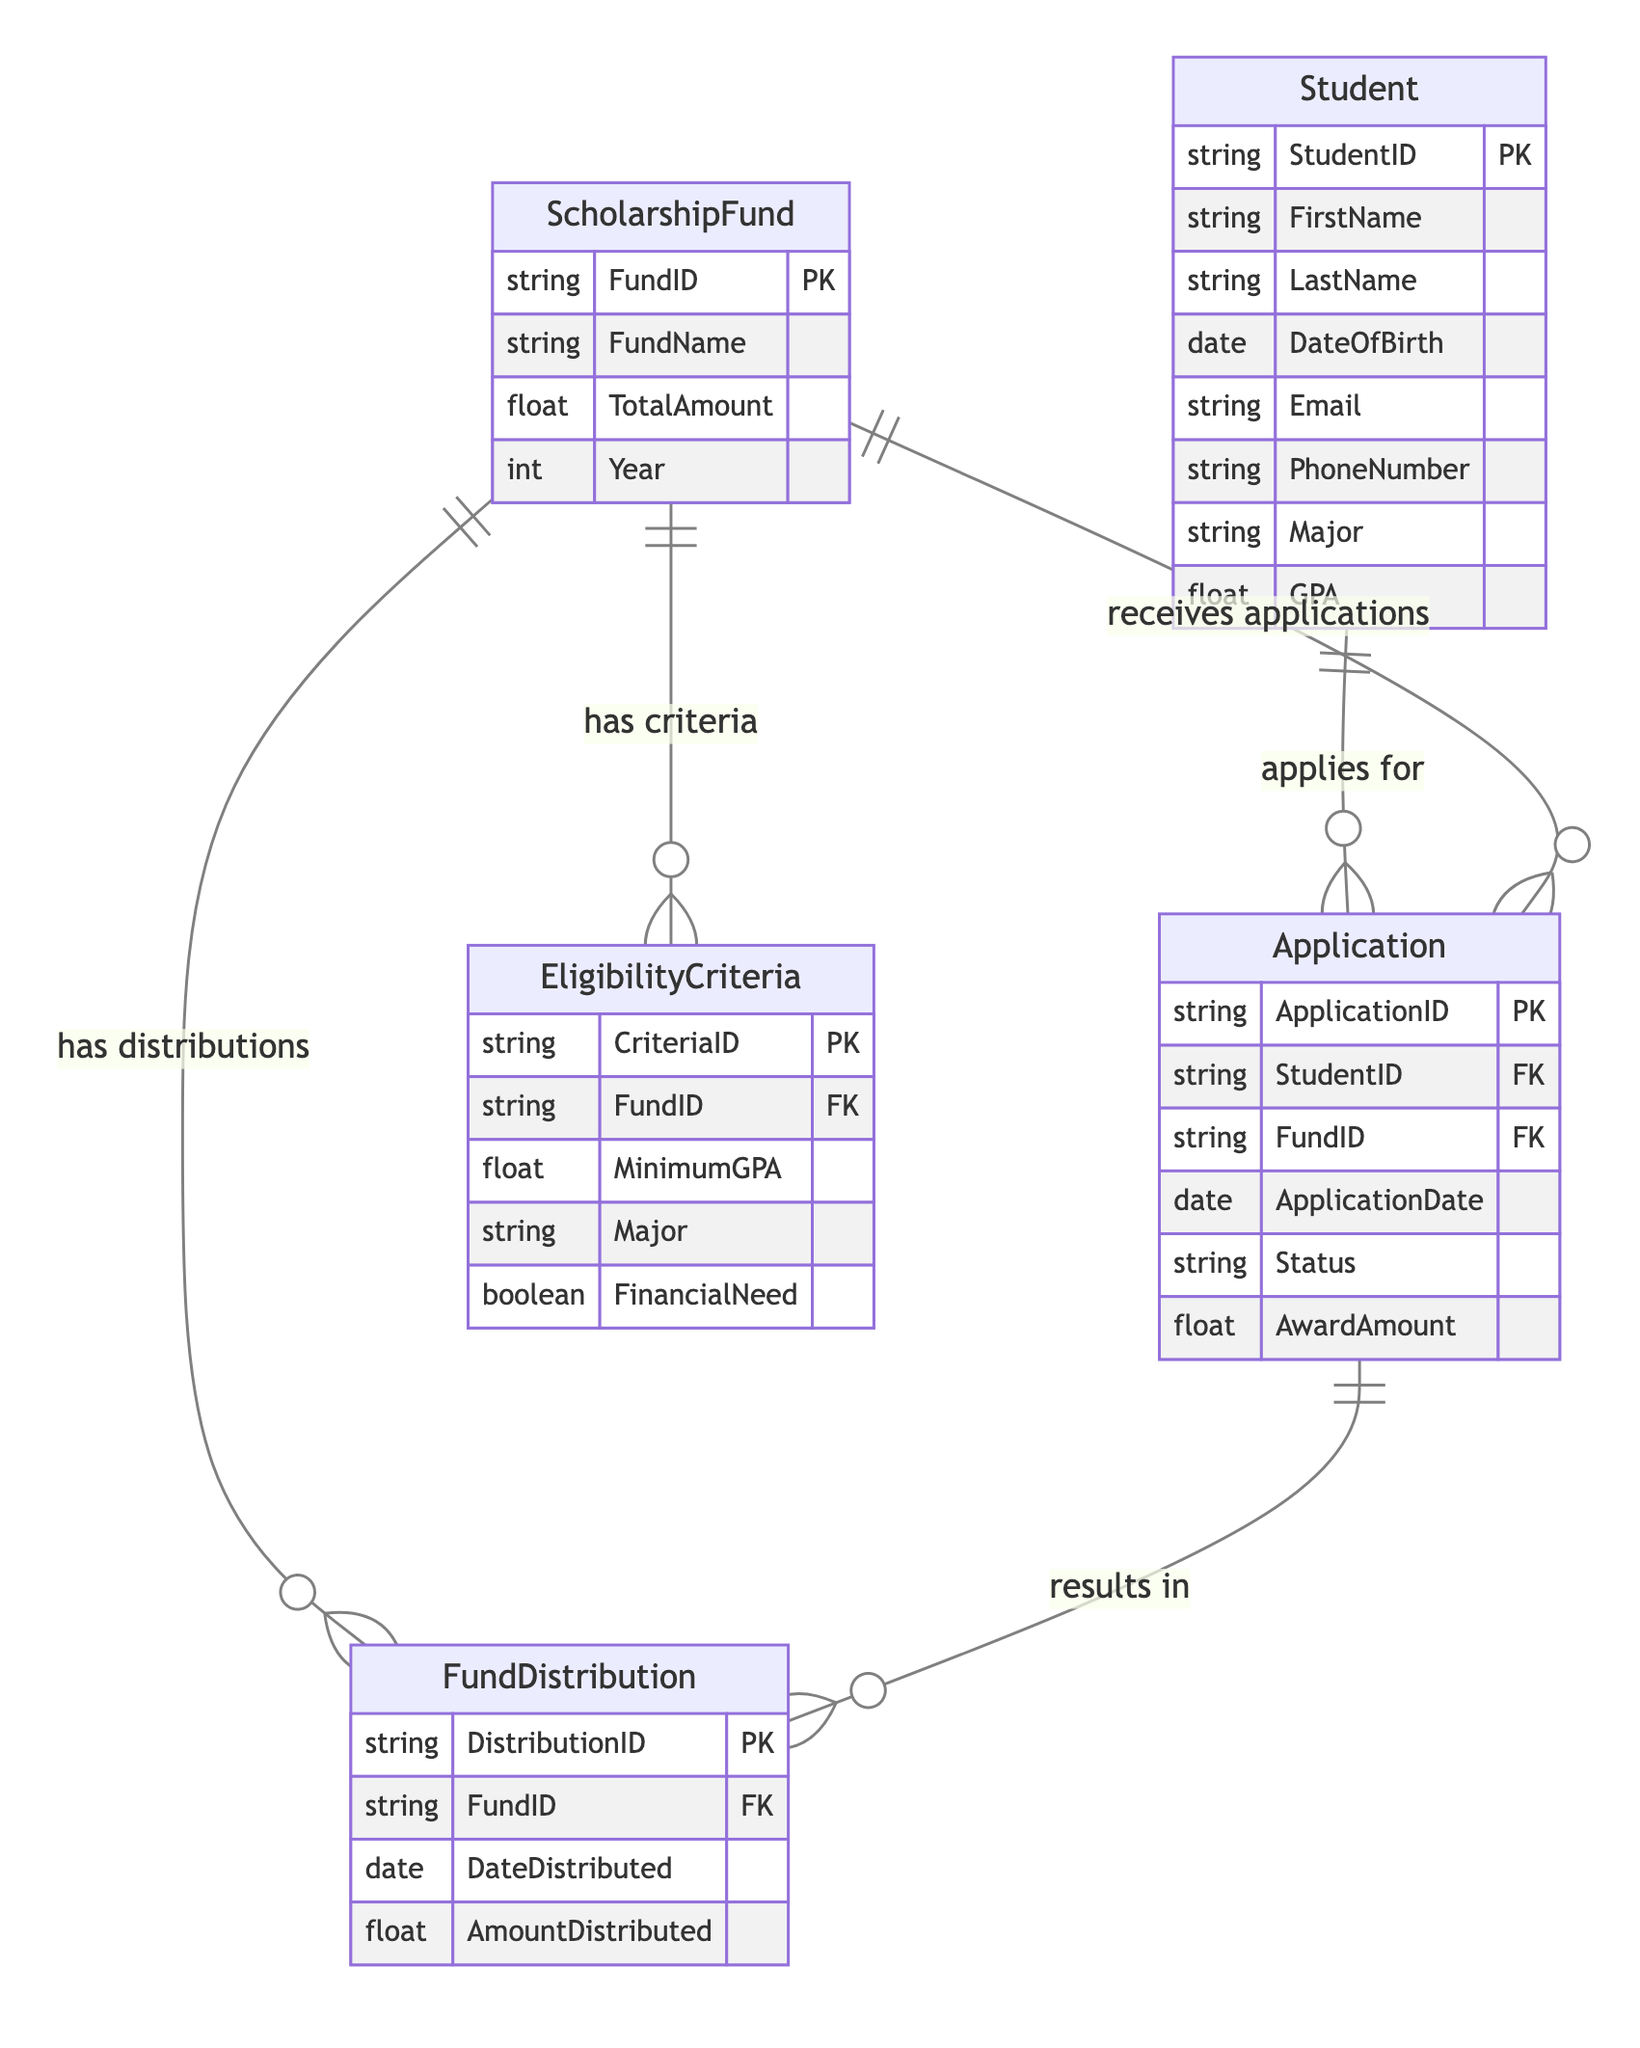What is the primary key of the Student entity? The primary key of the Student entity is indicated in the diagram as StudentID, which uniquely identifies each student in the database.
Answer: StudentID How many entities are present in the diagram? The diagram shows a total of five entities: Student, ScholarshipFund, EligibilityCriteria, Application, and FundDistribution, as represented by different boxes in the diagram.
Answer: Five What relationship does the Application entity have with the FundDistribution entity? The relationship between the Application entity and the FundDistribution entity is labeled "results in," indicating that applications lead to fund distributions based on their outcomes.
Answer: results in Which entity specifies the financial need criteria for scholarships? The EligibilityCriteria entity includes financial need as one of its attributes, indicating that it specifies the financial need criteria for scholarship applications.
Answer: EligibilityCriteria What is the foreign key in the Application entity that refers to ScholarshipFund? The foreign key in the Application entity that refers to the ScholarshipFund is FundID, which connects the application to the specific scholarship fund applied for.
Answer: FundID What is the relationship between the ScholarshipFund and the EligibilityCriteria? The ScholarshipFund has a relationship with the EligibilityCriteria, indicated as "has criteria," meaning each fund can have specific eligibility requirements associated with it.
Answer: has criteria What is the attribute in the EligibilityCriteria that determines the minimum GPA requirement? The attribute that determines the minimum GPA requirement in the EligibilityCriteria entity is MinimumGPA, which specifies the least GPA a student must have to be eligible for the fund.
Answer: MinimumGPA How does a Student apply for a ScholarshipFund according to the diagram? A Student applies for a ScholarshipFund through the Application entity, which indicates that students can submit applications to be considered for various scholarship funds.
Answer: applies for How many relationships are shown in the diagram? The diagram shows a total of five relationships connecting the entities, as represented by the lines and labels specifying how the entities interact with one another.
Answer: Five 